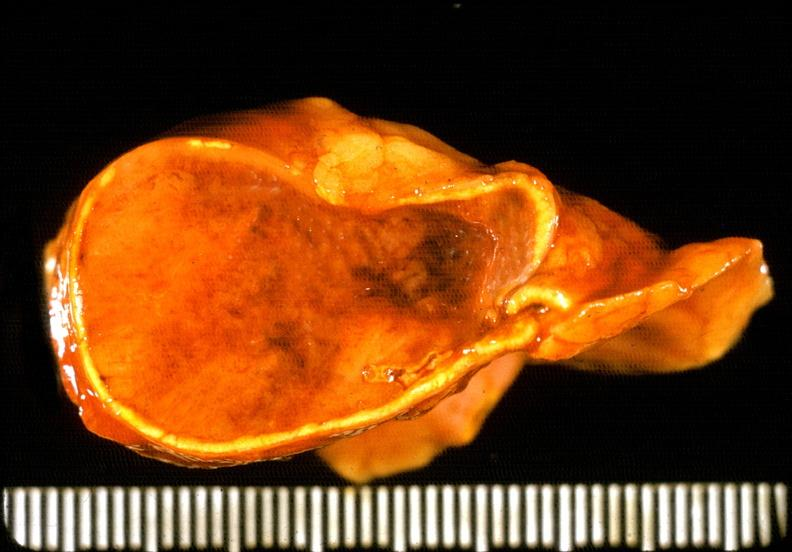s endocrine present?
Answer the question using a single word or phrase. Yes 